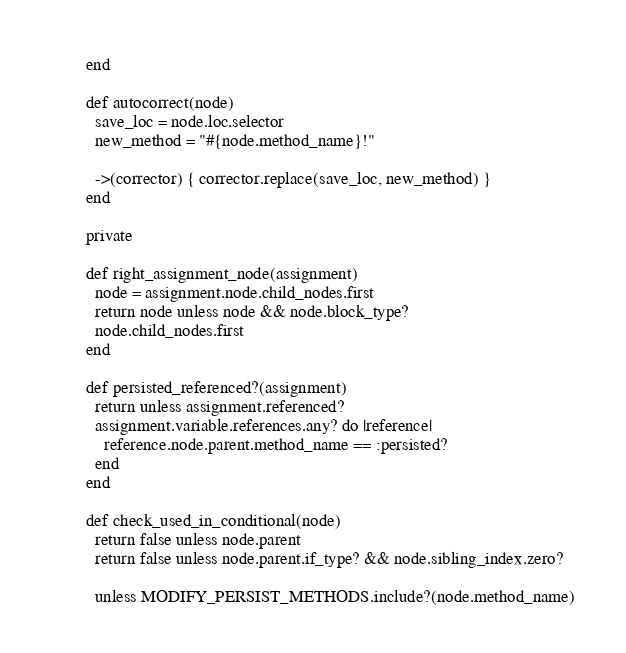<code> <loc_0><loc_0><loc_500><loc_500><_Ruby_>        end

        def autocorrect(node)
          save_loc = node.loc.selector
          new_method = "#{node.method_name}!"

          ->(corrector) { corrector.replace(save_loc, new_method) }
        end

        private

        def right_assignment_node(assignment)
          node = assignment.node.child_nodes.first
          return node unless node && node.block_type?
          node.child_nodes.first
        end

        def persisted_referenced?(assignment)
          return unless assignment.referenced?
          assignment.variable.references.any? do |reference|
            reference.node.parent.method_name == :persisted?
          end
        end

        def check_used_in_conditional(node)
          return false unless node.parent
          return false unless node.parent.if_type? && node.sibling_index.zero?

          unless MODIFY_PERSIST_METHODS.include?(node.method_name)</code> 